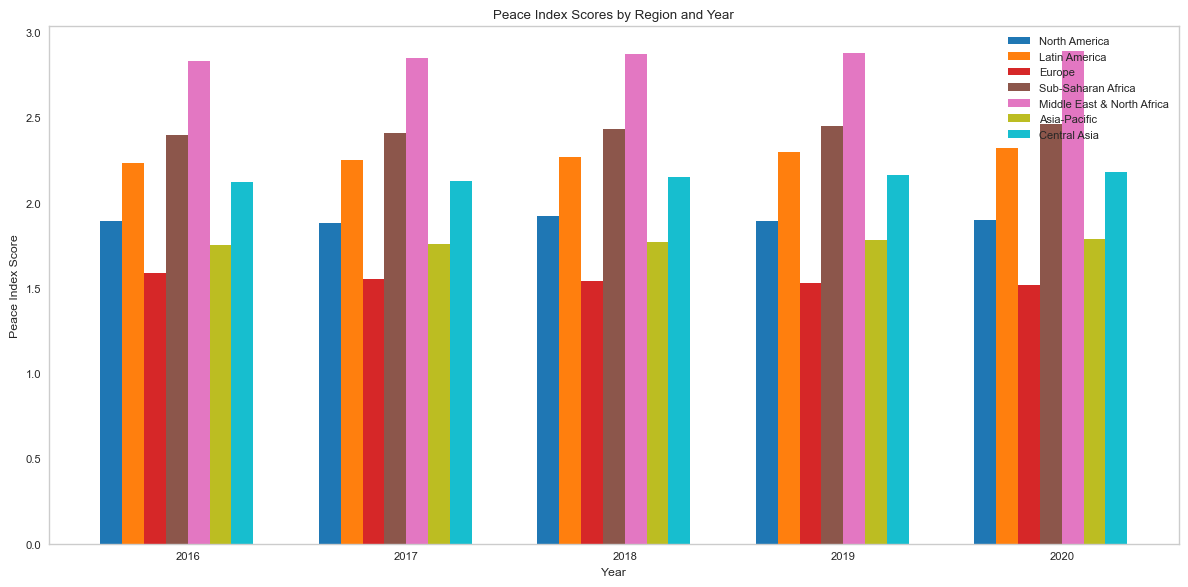What region has the highest Peace Index Score in 2020? To determine the highest Peace Index Score for 2020, look at the last group of bars representing various regions. Compare their heights. The Middle East & North Africa has the tallest bar in 2020.
Answer: Middle East & North Africa Which region showed a decrease in their Peace Index Score from 2016 to 2020? To find this, compare the heights of the bars for each region from 2016 to 2020. Europe is the only region where each year's bar is slightly shorter than the previous year.
Answer: Europe What is the average Peace Index Score for North America over the years 2016 to 2020? Add the Peace Index Scores for North America for each year from 2016 to 2020: (1.89, 1.88, 1.92, 1.89, 1.90). The sum is 9.48. Divide this by 5 (the number of years). 9.48 / 5 = 1.896.
Answer: 1.896 Compare the Peace Index Scores of Sub-Saharan Africa and Asia-Pacific in 2018. Which one is higher? Look at the bars for Sub-Saharan Africa and Asia-Pacific for the year 2018. Compare their heights to determine the higher one. Sub-Saharan Africa's bar is taller, indicating a higher score.
Answer: Sub-Saharan Africa Which region had the smallest change in Peace Index Score between 2016 and 2020? For each region, find the difference between the scores in 2016 and 2020. The region with the smallest difference is North America, where the score changed minimally (1.89 in 2016 to 1.90 in 2020, a change of 0.01).
Answer: North America How many regions have a Peace Index Score greater than 2.00 in 2019? Look at the 2019 bars and count how many regions have their bars above the 2.00 mark on the y-axis. The regions are Latin America, Sub-Saharan Africa, Middle East & North Africa, and Central Asia. This gives us a total of 4 regions.
Answer: 4 Is the trend in Peace Index Score for Asia-Pacific increasing or decreasing from 2016 to 2020? Check the bars for Asia-Pacific from 2016 to 2020 to see if they are getting taller or shorter. The trend shows a gradual increase in the bar height each year.
Answer: Increasing What is the difference in Peace Index Scores between Europe and Latin America in 2017? Subtract Europe's 2017 score (1.55) from Latin America's 2017 score (2.25). The difference is 2.25 - 1.55 = 0.70.
Answer: 0.70 Which region exhibited the highest consistency in Peace Index Scores from 2016 to 2020? Look for the region with the flattest trend in their bars' heights over the years. North America's bars are quite consistent compared to others, indicating higher consistency.
Answer: North America By how much did the Peace Index Score for Middle East & North Africa increase from 2016 to 2020? Subtract the 2016 score (2.83) for Middle East & North Africa from the 2020 score (2.89). The increase is 2.89 - 2.83 = 0.06.
Answer: 0.06 